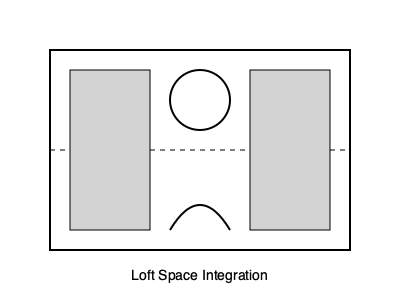In the context of loft design, how can the Golden Ratio ($\phi \approx 1.618$) be applied to harmoniously integrate industrial elements with classic architectural features? Provide a specific example using the dimensions of a feature in the loft space. To integrate industrial elements with classic architectural features using the Golden Ratio:

1. Understand the Golden Ratio: $\phi = \frac{1+\sqrt{5}}{2} \approx 1.618$

2. Apply to loft design:
   a. Choose a feature, e.g., an industrial-style bookshelf
   b. Determine its height (h) based on ceiling height
   c. Calculate width (w) using Golden Ratio: $\frac{h}{w} = \phi$

3. Example calculation:
   a. Assume ceiling height = 3.6 m
   b. Choose bookshelf height (h) = 2.4 m
   c. Calculate width: $w = \frac{h}{\phi} = \frac{2.4}{1.618} \approx 1.48$ m

4. Integration:
   a. Use industrial materials (e.g., steel, reclaimed wood)
   b. Incorporate classic molding or trim around the bookshelf
   c. Ensure the bookshelf's proportions (2.4 m x 1.48 m) follow the Golden Ratio

5. Extend the principle:
   a. Apply to other elements (e.g., windows, room divisions)
   b. Create a cohesive design throughout the loft

By using the Golden Ratio, industrial elements can be seamlessly integrated with classic features, creating a harmonious balance between traditional and contemporary design in the loft space.
Answer: Apply Golden Ratio ($\phi \approx 1.618$) to feature dimensions (e.g., 2.4 m x 1.48 m bookshelf) 